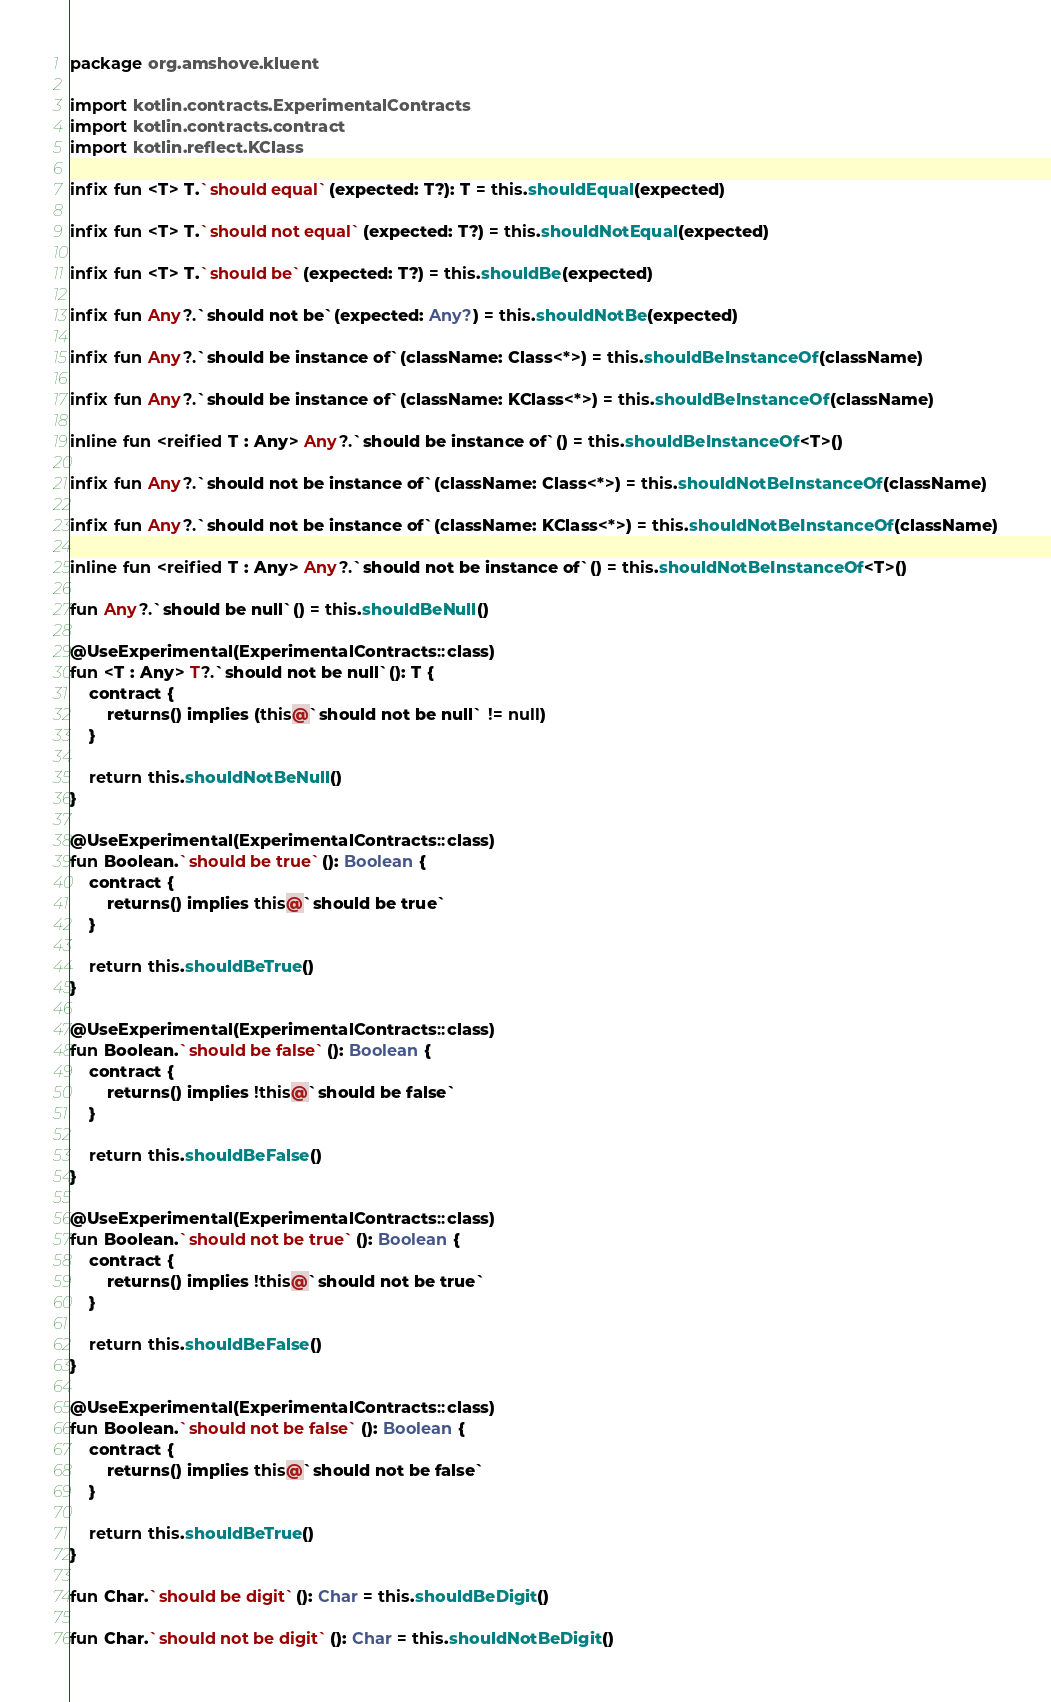Convert code to text. <code><loc_0><loc_0><loc_500><loc_500><_Kotlin_>package org.amshove.kluent

import kotlin.contracts.ExperimentalContracts
import kotlin.contracts.contract
import kotlin.reflect.KClass

infix fun <T> T.`should equal`(expected: T?): T = this.shouldEqual(expected)

infix fun <T> T.`should not equal`(expected: T?) = this.shouldNotEqual(expected)

infix fun <T> T.`should be`(expected: T?) = this.shouldBe(expected)

infix fun Any?.`should not be`(expected: Any?) = this.shouldNotBe(expected)

infix fun Any?.`should be instance of`(className: Class<*>) = this.shouldBeInstanceOf(className)

infix fun Any?.`should be instance of`(className: KClass<*>) = this.shouldBeInstanceOf(className)

inline fun <reified T : Any> Any?.`should be instance of`() = this.shouldBeInstanceOf<T>()

infix fun Any?.`should not be instance of`(className: Class<*>) = this.shouldNotBeInstanceOf(className)

infix fun Any?.`should not be instance of`(className: KClass<*>) = this.shouldNotBeInstanceOf(className)

inline fun <reified T : Any> Any?.`should not be instance of`() = this.shouldNotBeInstanceOf<T>()

fun Any?.`should be null`() = this.shouldBeNull()

@UseExperimental(ExperimentalContracts::class)
fun <T : Any> T?.`should not be null`(): T {
    contract {
        returns() implies (this@`should not be null` != null)
    }

    return this.shouldNotBeNull()
}

@UseExperimental(ExperimentalContracts::class)
fun Boolean.`should be true`(): Boolean {
    contract {
        returns() implies this@`should be true`
    }

    return this.shouldBeTrue()
}

@UseExperimental(ExperimentalContracts::class)
fun Boolean.`should be false`(): Boolean {
    contract {
        returns() implies !this@`should be false`
    }

    return this.shouldBeFalse()
}

@UseExperimental(ExperimentalContracts::class)
fun Boolean.`should not be true`(): Boolean {
    contract {
        returns() implies !this@`should not be true`
    }

    return this.shouldBeFalse()
}

@UseExperimental(ExperimentalContracts::class)
fun Boolean.`should not be false`(): Boolean {
    contract {
        returns() implies this@`should not be false`
    }

    return this.shouldBeTrue()
}

fun Char.`should be digit`(): Char = this.shouldBeDigit()

fun Char.`should not be digit`(): Char = this.shouldNotBeDigit()
</code> 